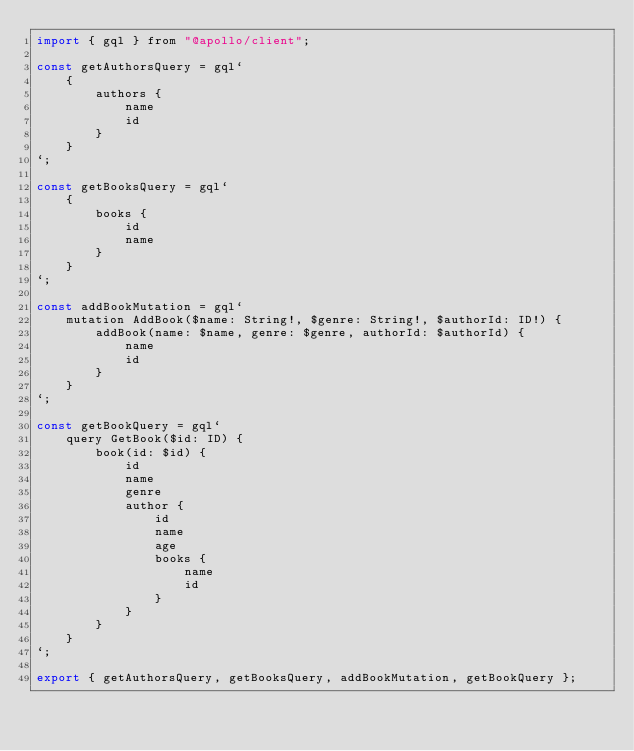<code> <loc_0><loc_0><loc_500><loc_500><_JavaScript_>import { gql } from "@apollo/client";

const getAuthorsQuery = gql`
    {
        authors {
            name
            id
        }
    }
`;

const getBooksQuery = gql`
    {
        books {
            id
            name
        }
    }
`;

const addBookMutation = gql`
    mutation AddBook($name: String!, $genre: String!, $authorId: ID!) {
        addBook(name: $name, genre: $genre, authorId: $authorId) {
            name
            id
        }
    }
`;

const getBookQuery = gql`
    query GetBook($id: ID) {
        book(id: $id) {
            id
            name
            genre
            author {
                id
                name
                age
                books {
                    name
                    id
                }
            }
        }
    }
`;

export { getAuthorsQuery, getBooksQuery, addBookMutation, getBookQuery };
</code> 